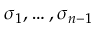Convert formula to latex. <formula><loc_0><loc_0><loc_500><loc_500>\sigma _ { 1 } , \dots , \sigma _ { n - 1 }</formula> 